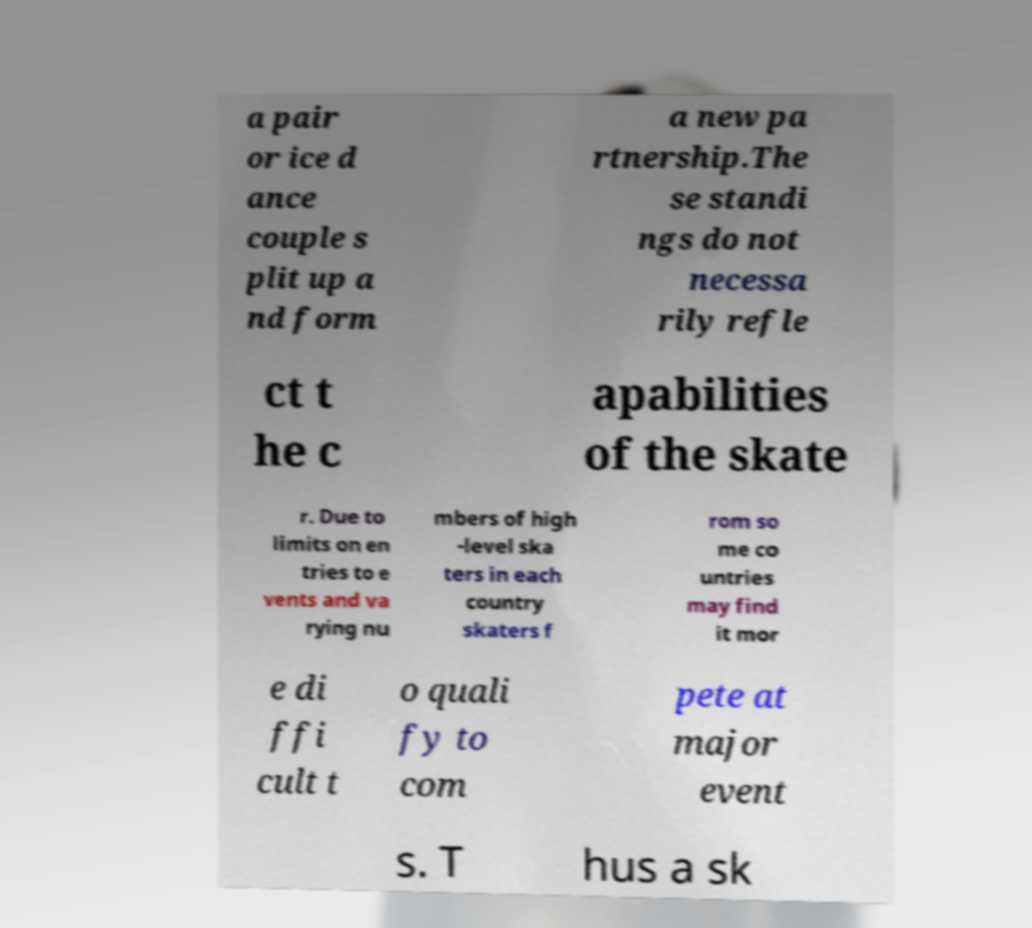Can you read and provide the text displayed in the image?This photo seems to have some interesting text. Can you extract and type it out for me? a pair or ice d ance couple s plit up a nd form a new pa rtnership.The se standi ngs do not necessa rily refle ct t he c apabilities of the skate r. Due to limits on en tries to e vents and va rying nu mbers of high -level ska ters in each country skaters f rom so me co untries may find it mor e di ffi cult t o quali fy to com pete at major event s. T hus a sk 